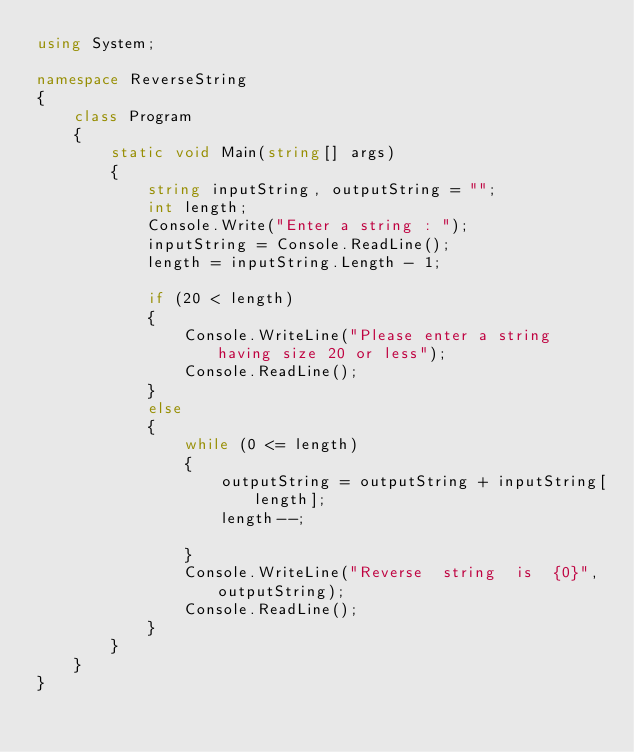<code> <loc_0><loc_0><loc_500><loc_500><_C#_>using System;

namespace ReverseString
{
    class Program
    {
        static void Main(string[] args)
        {
            string inputString, outputString = "";
            int length;
            Console.Write("Enter a string : ");
            inputString = Console.ReadLine();
            length = inputString.Length - 1;

            if (20 < length)
            {
                Console.WriteLine("Please enter a string having size 20 or less");
                Console.ReadLine();
            }
            else
            {
                while (0 <= length)
                {
                    outputString = outputString + inputString[length];
                    length--;

                }
                Console.WriteLine("Reverse  string  is  {0}", outputString);
                Console.ReadLine();
            }
        }
    }
}</code> 